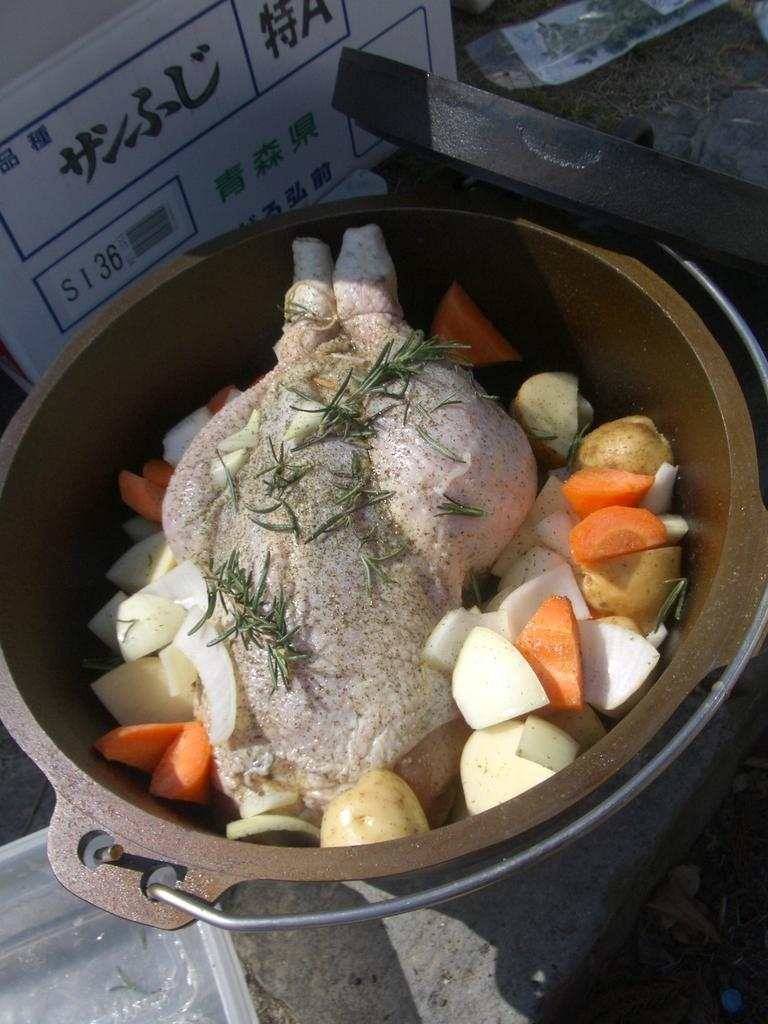What is in the vessel that is visible in the image? There is a vessel containing cut vegetables and chicken in the image. What is located at the top of the image? There is a board at the top of the image. What object can be seen in the top right of the image? There is an object in the top right of the image. What type of hope can be seen in the image? There is no reference to hope in the image; it features a vessel with cut vegetables and chicken, a board, and an object. What sound can be heard coming from the object in the image? There is no sound present in the image, as it is a still image. 